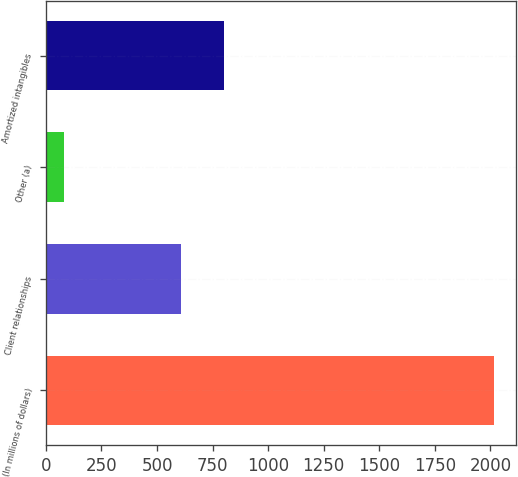<chart> <loc_0><loc_0><loc_500><loc_500><bar_chart><fcel>(In millions of dollars)<fcel>Client relationships<fcel>Other (a)<fcel>Amortized intangibles<nl><fcel>2014<fcel>609<fcel>83<fcel>802.1<nl></chart> 